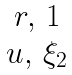<formula> <loc_0><loc_0><loc_500><loc_500>\begin{matrix} r , \, 1 \\ u , \, \xi _ { 2 } \end{matrix}</formula> 